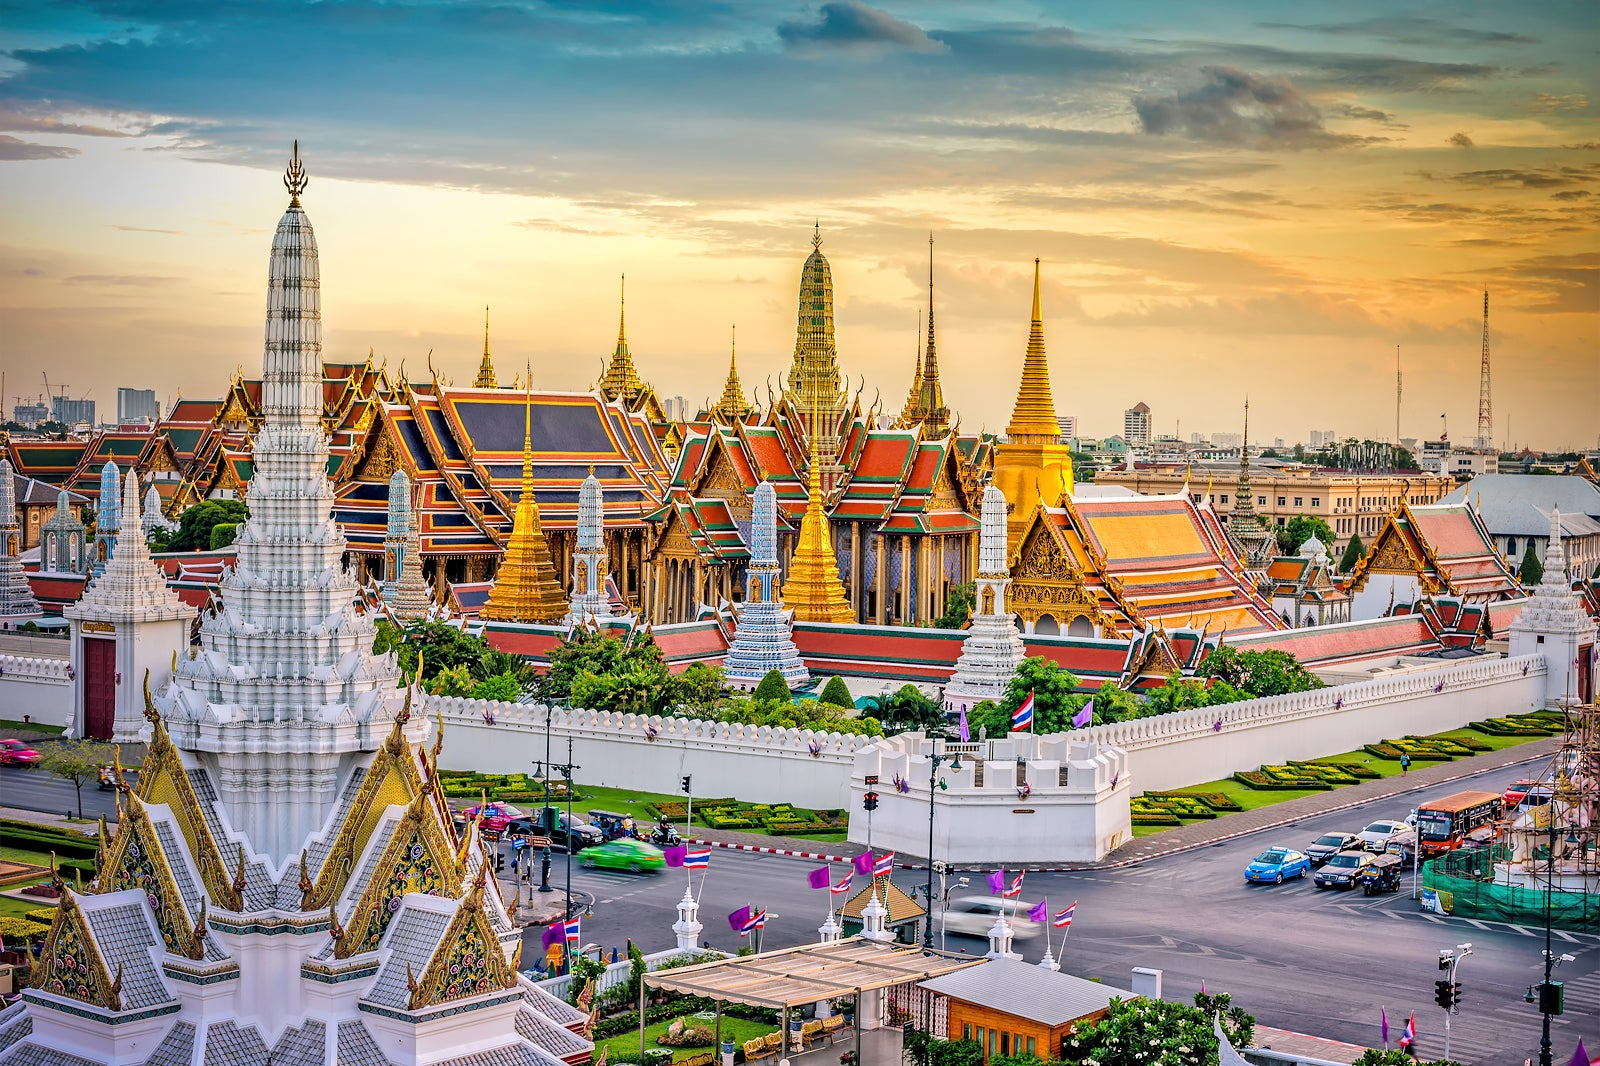What historical events have taken place at the Grand Palace? The Grand Palace has been the site of numerous significant historical events since its construction in 1782. It was the official residence of the Kings of Siam (later Thailand) until 1925. It has hosted important royal ceremonies, coronations, and state functions. The current King, although not residing there, uses it for official events. Many treaties and diplomatic negotiations occurred here, contributing to Thailand's international relationships. The palace has also been pivotal during Thai holidays and royal festivals, serving as a central cultural landmark. 